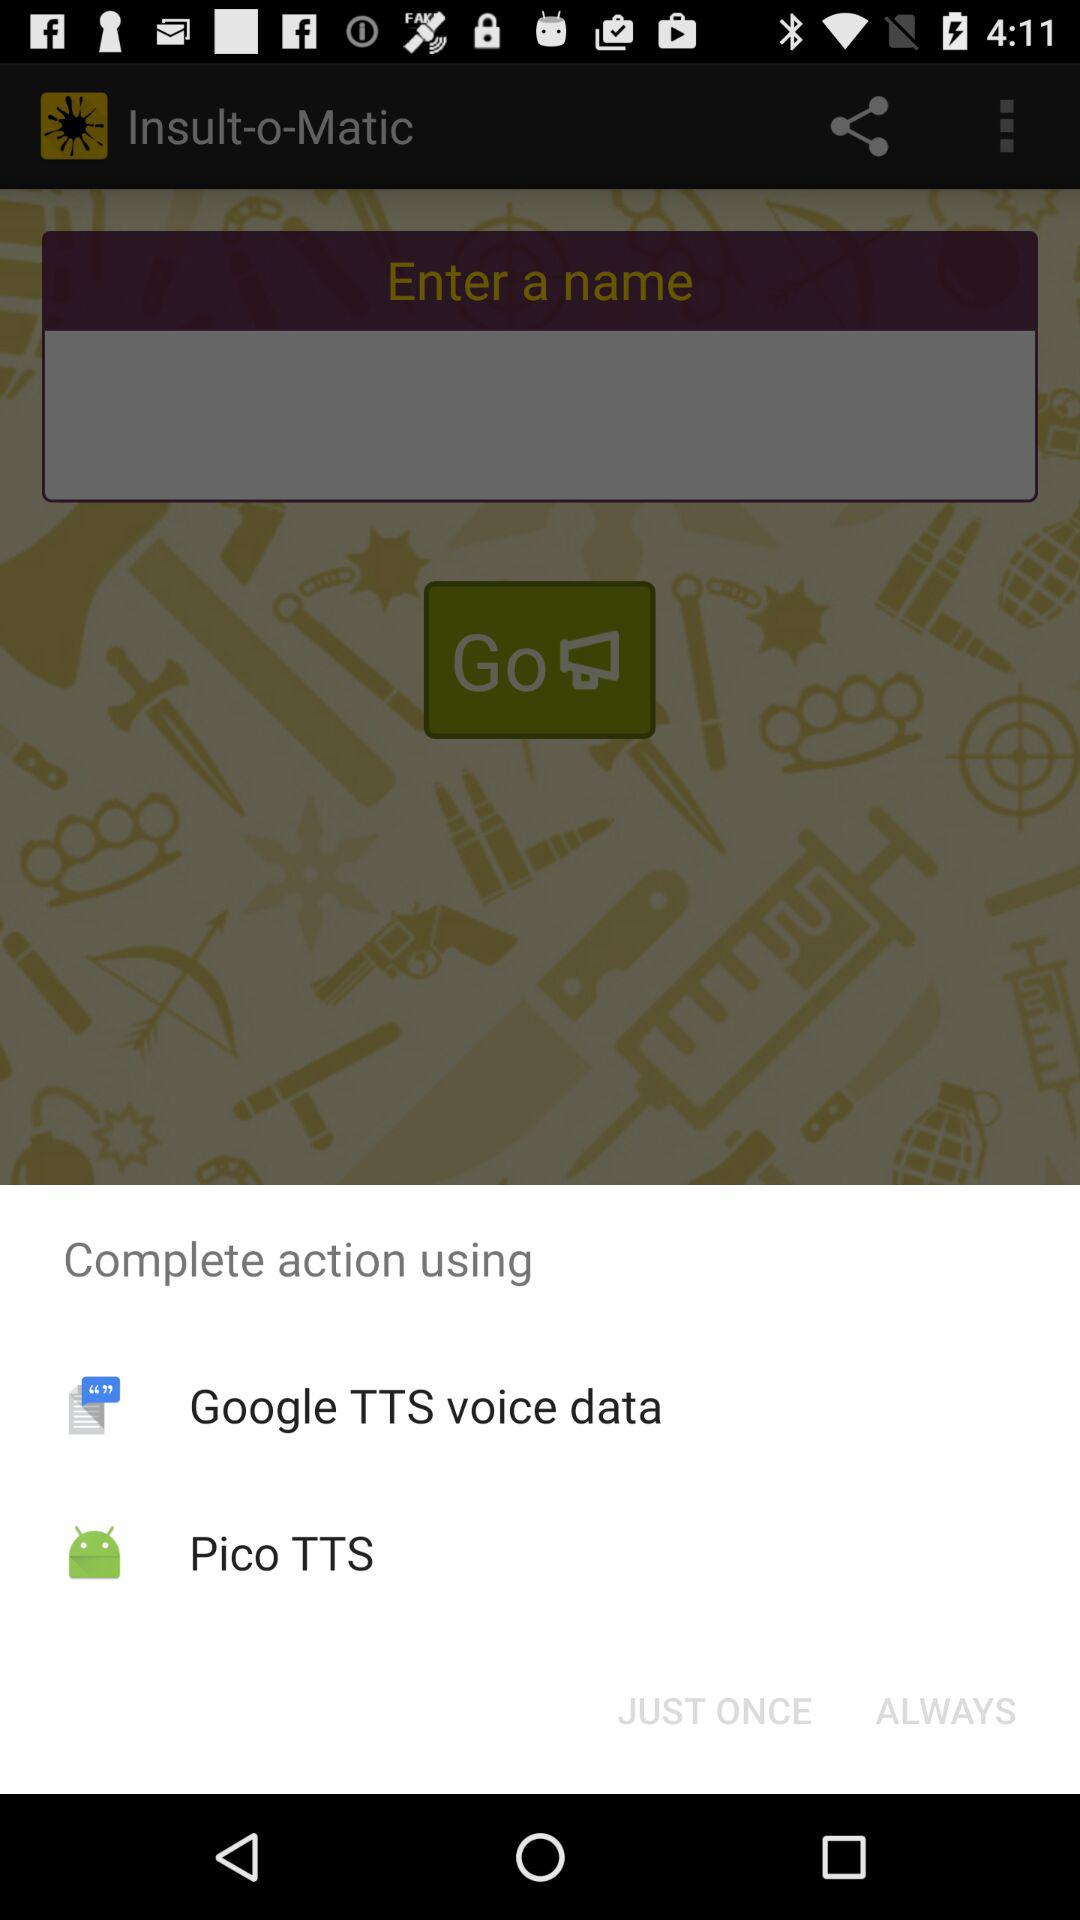Through what app can we share data? You can share data through "Google TTS voice data" and "Pico TTS". 